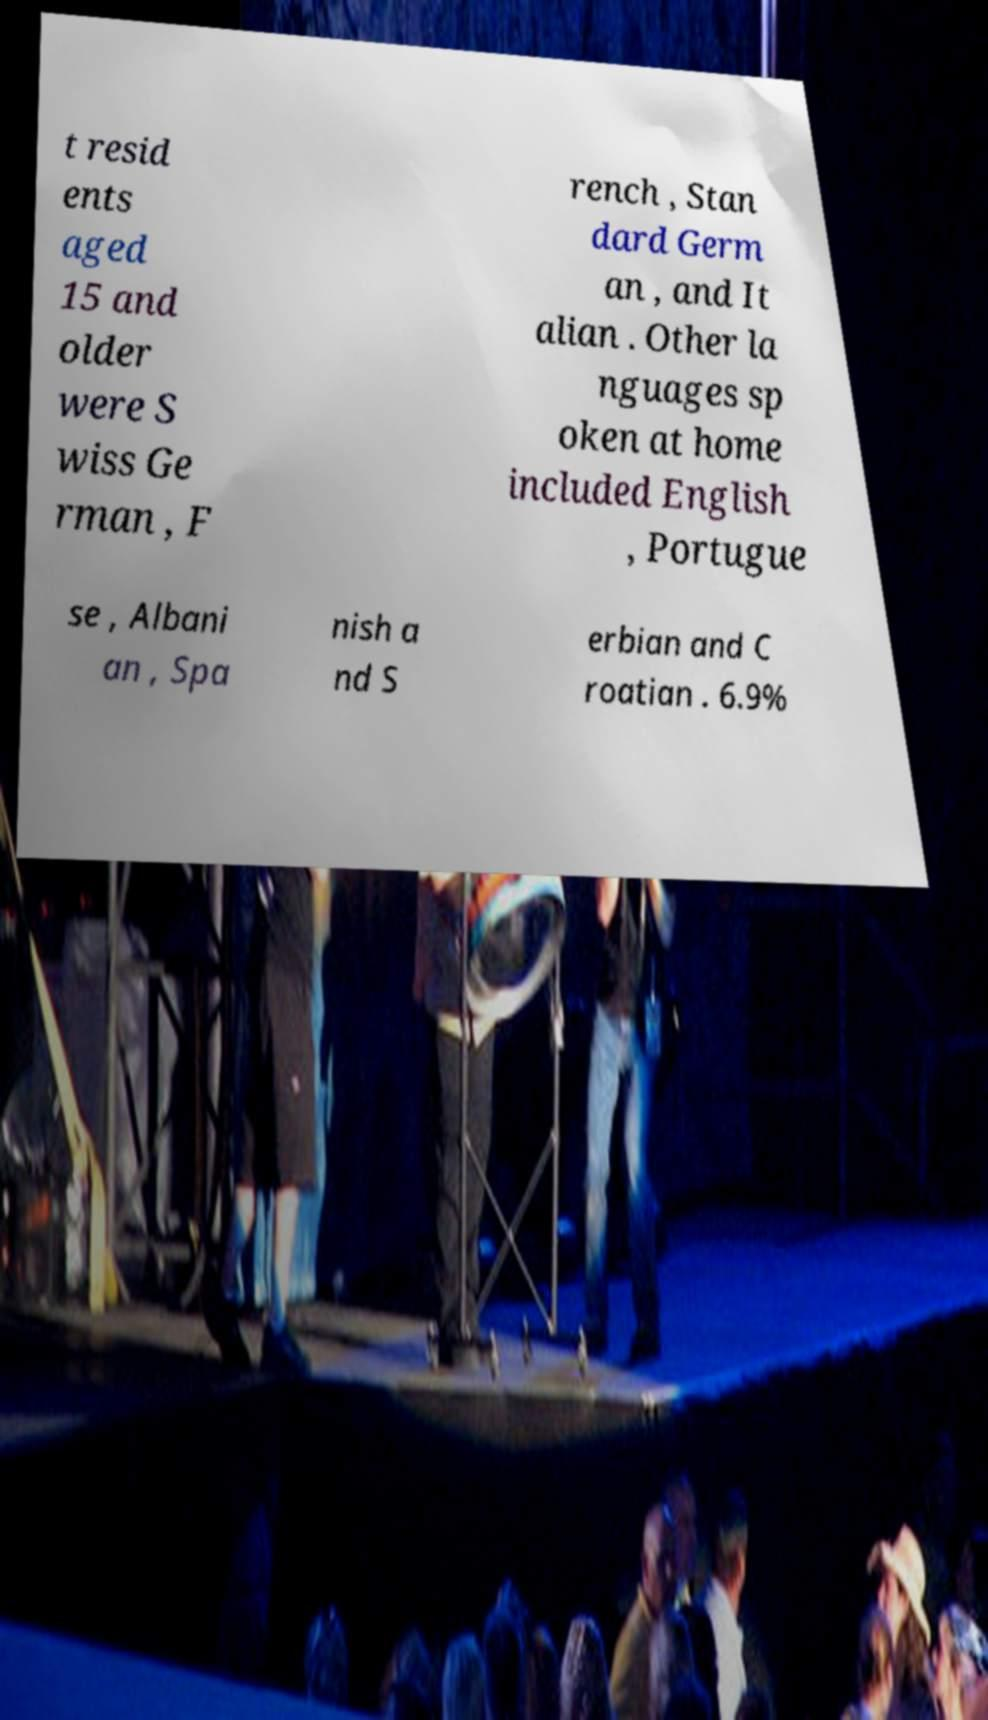Could you assist in decoding the text presented in this image and type it out clearly? t resid ents aged 15 and older were S wiss Ge rman , F rench , Stan dard Germ an , and It alian . Other la nguages sp oken at home included English , Portugue se , Albani an , Spa nish a nd S erbian and C roatian . 6.9% 